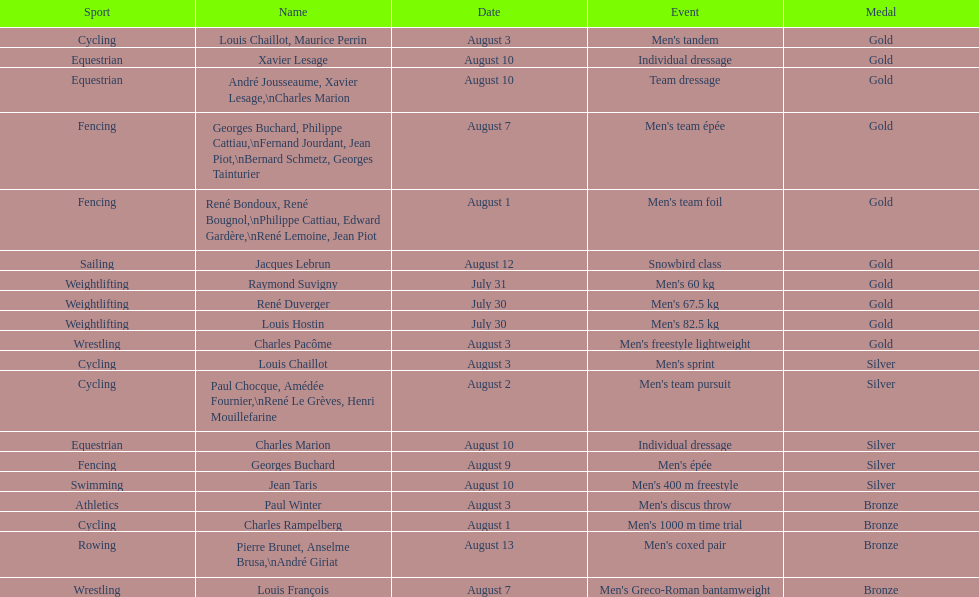What sport is listed first? Cycling. 